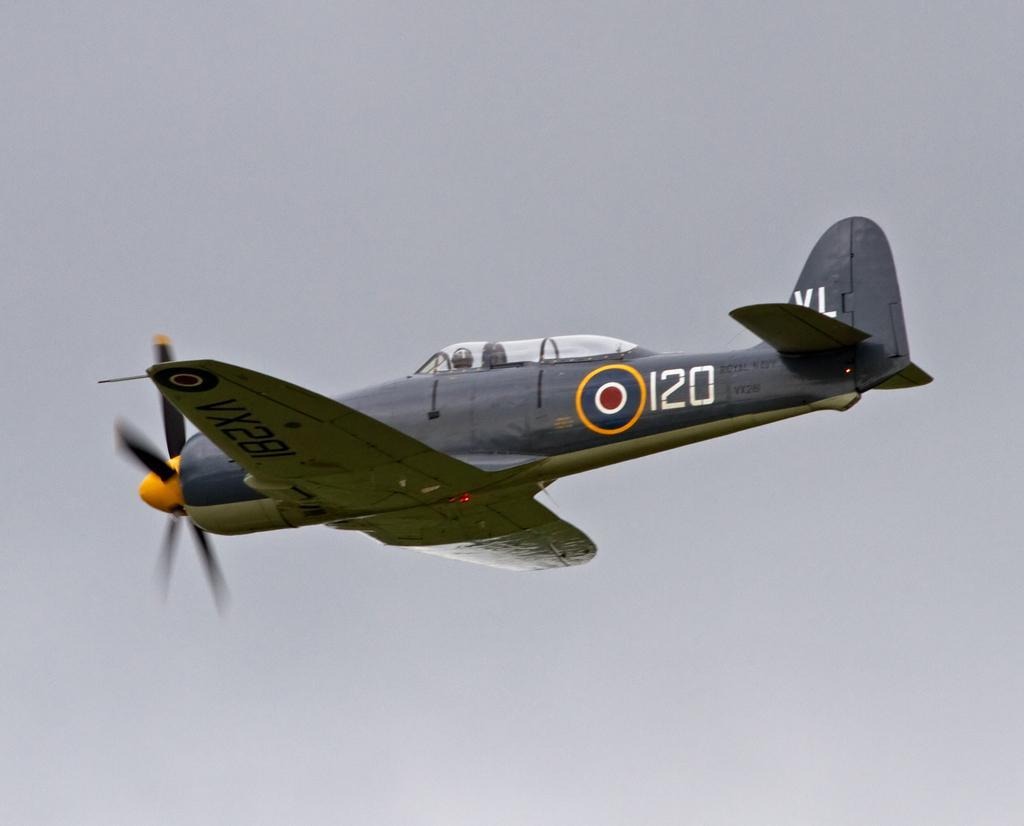What is the main subject of the image? The main subject of the image is an airplane. What is the airplane doing in the image? The airplane is flying in the sky. Are there any passengers inside the airplane? Yes, there are people inside the airplane. What is the condition of the sky in the image? The sky is clear in the image. Can you tell me how many cattle are visible from the airplane in the image? There are no cattle visible in the image, as it features an airplane flying in the sky. What type of sneeze can be heard coming from the passengers in the image? There is no indication of any sneezing or sounds in the image, as it only shows an airplane flying in the sky. 